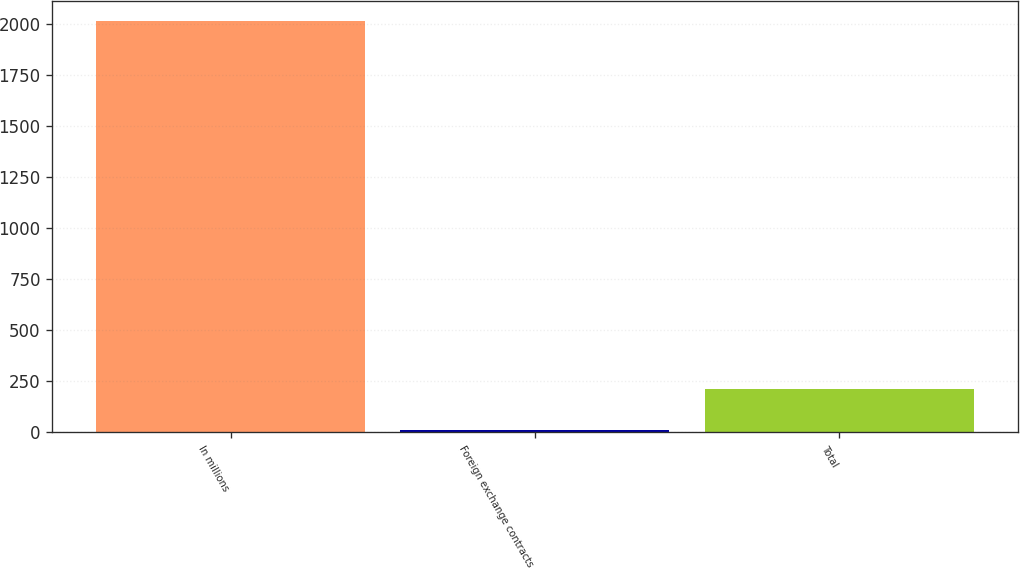<chart> <loc_0><loc_0><loc_500><loc_500><bar_chart><fcel>In millions<fcel>Foreign exchange contracts<fcel>Total<nl><fcel>2014<fcel>10<fcel>210.4<nl></chart> 